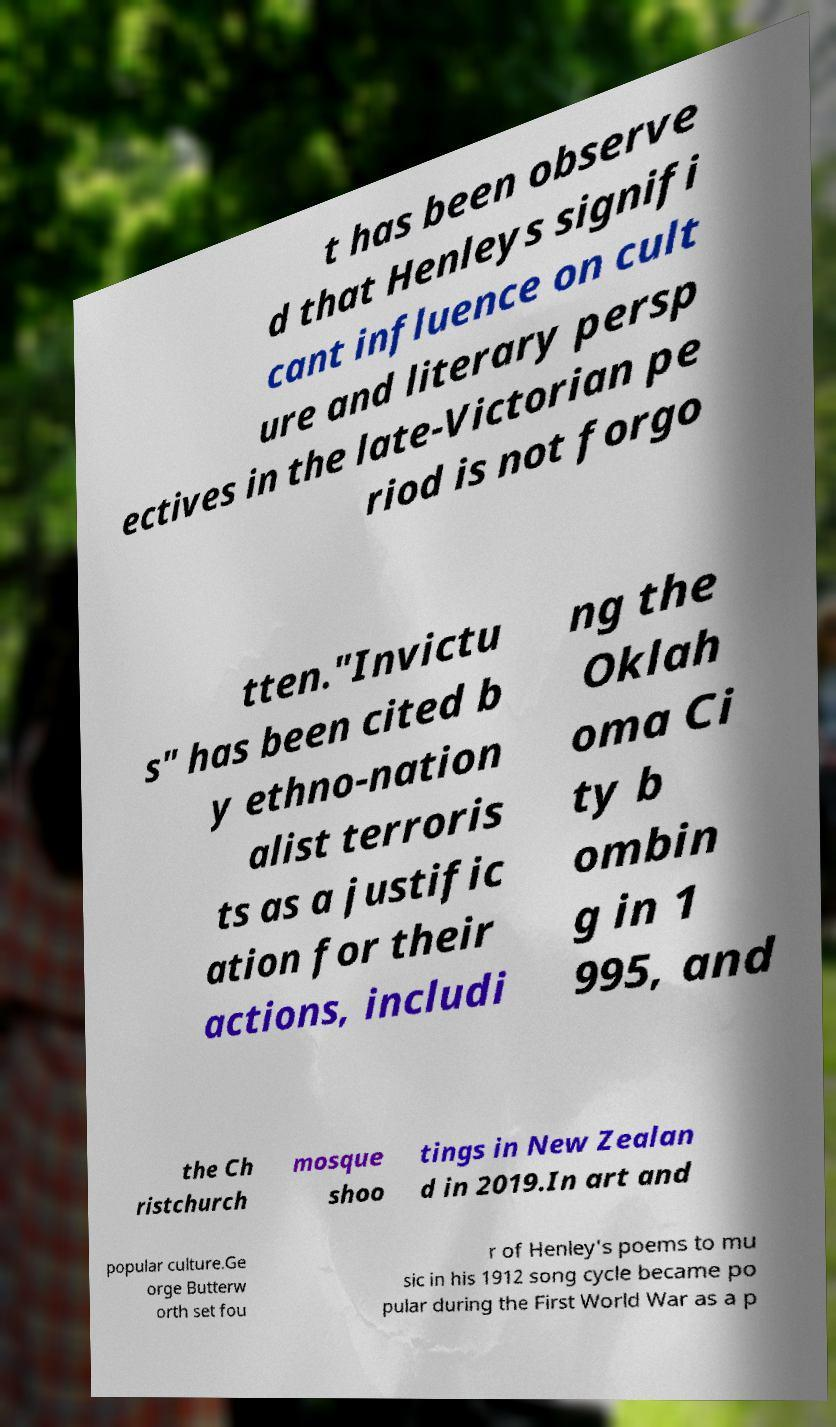There's text embedded in this image that I need extracted. Can you transcribe it verbatim? t has been observe d that Henleys signifi cant influence on cult ure and literary persp ectives in the late-Victorian pe riod is not forgo tten."Invictu s" has been cited b y ethno-nation alist terroris ts as a justific ation for their actions, includi ng the Oklah oma Ci ty b ombin g in 1 995, and the Ch ristchurch mosque shoo tings in New Zealan d in 2019.In art and popular culture.Ge orge Butterw orth set fou r of Henley's poems to mu sic in his 1912 song cycle became po pular during the First World War as a p 